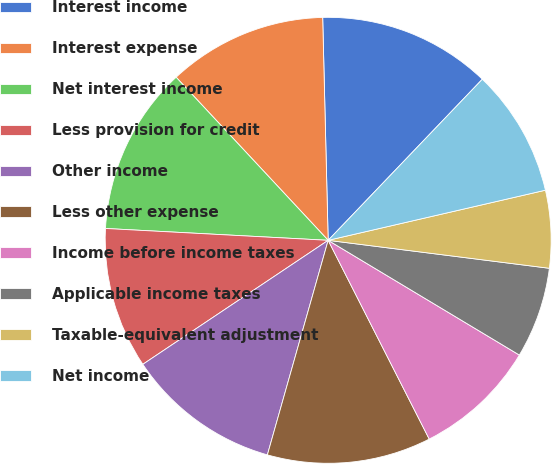Convert chart. <chart><loc_0><loc_0><loc_500><loc_500><pie_chart><fcel>Interest income<fcel>Interest expense<fcel>Net interest income<fcel>Less provision for credit<fcel>Other income<fcel>Less other expense<fcel>Income before income taxes<fcel>Applicable income taxes<fcel>Taxable-equivalent adjustment<fcel>Net income<nl><fcel>12.54%<fcel>11.55%<fcel>12.21%<fcel>10.23%<fcel>11.22%<fcel>11.88%<fcel>8.91%<fcel>6.6%<fcel>5.61%<fcel>9.24%<nl></chart> 